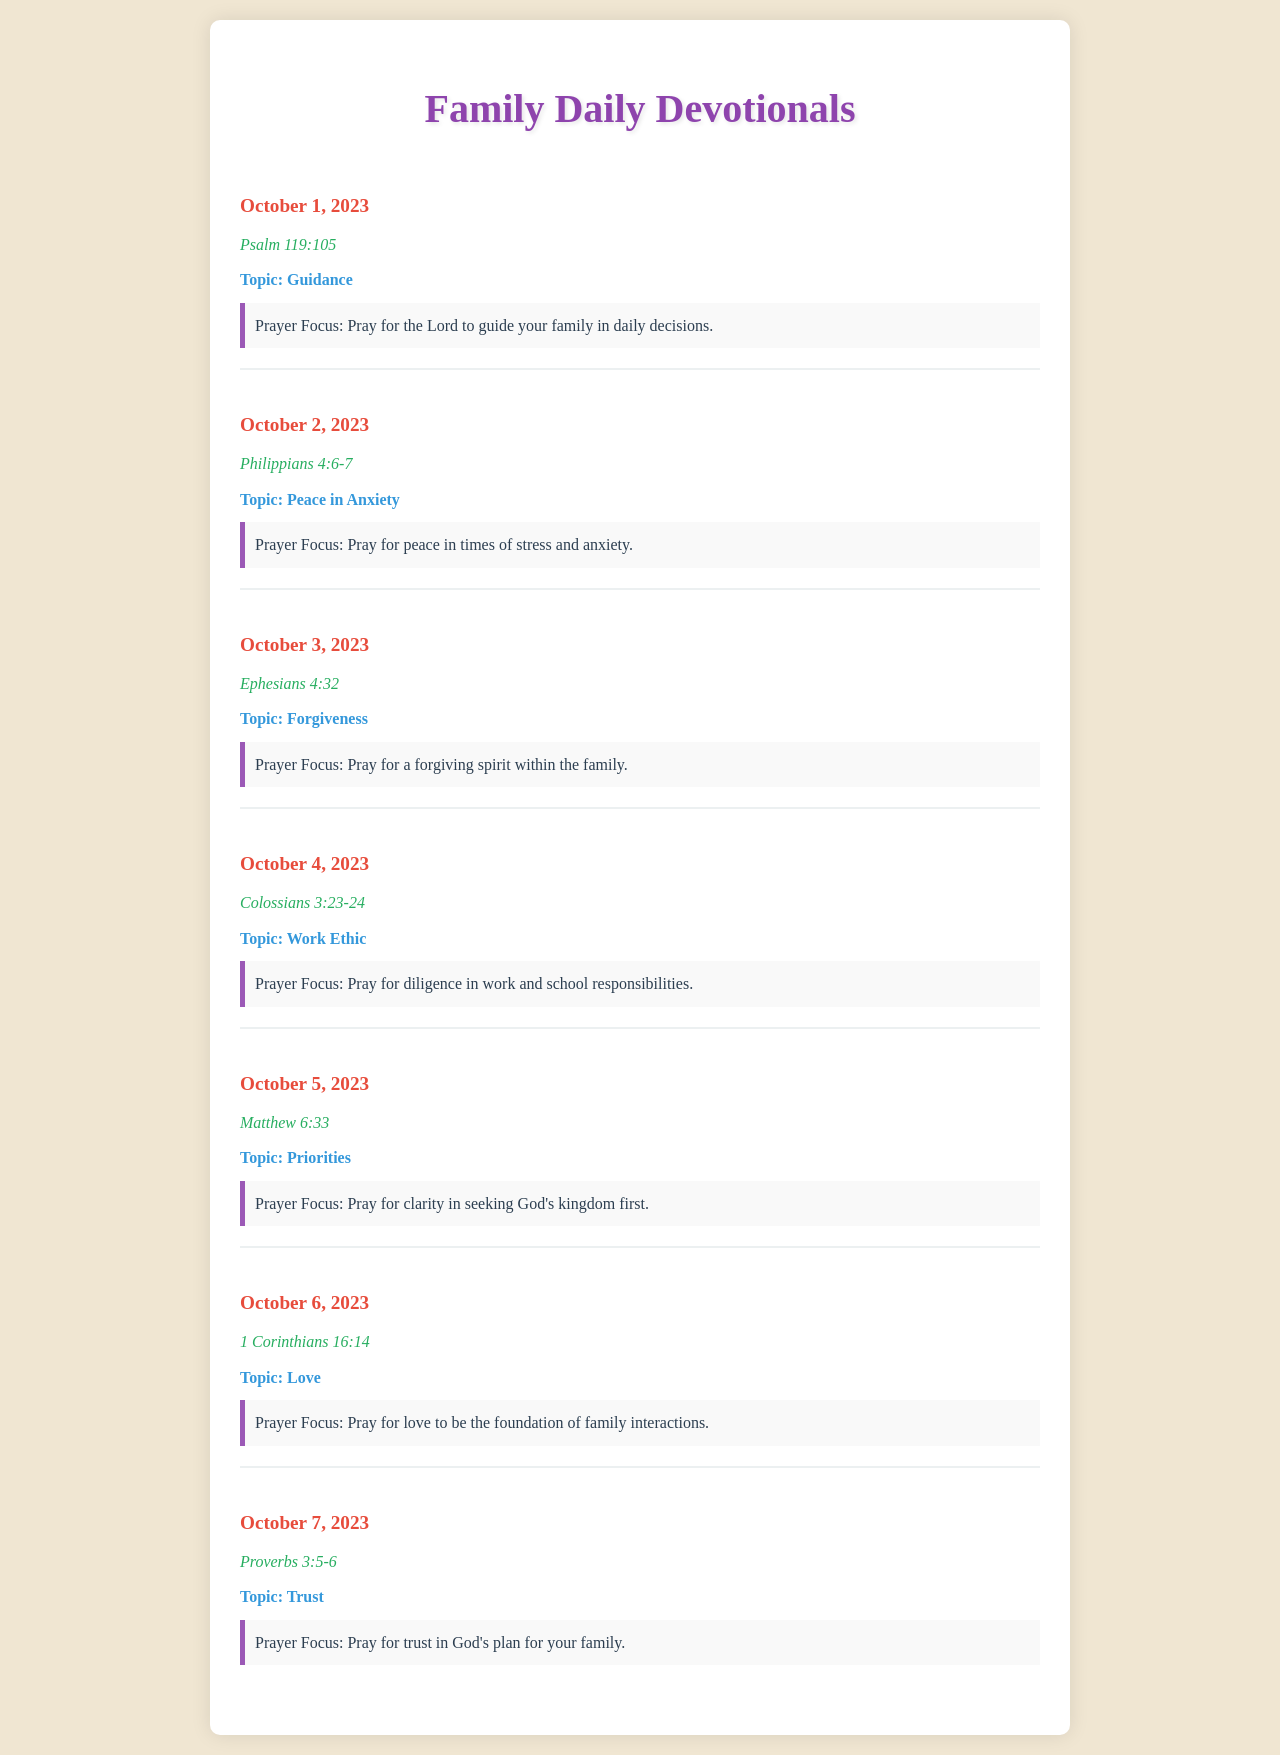What is the first scripture reading? The first scripture reading in the document is found under the date October 1, 2023.
Answer: Psalm 119:105 What is the prayer focus for October 3, 2023? The prayer focus for October 3, 2023 is listed as the same day under the topic of forgiveness.
Answer: Pray for a forgiving spirit within the family How many days of devotionals are listed? Counting from October 1 to October 7, there are seven entries for devotionals in the document.
Answer: 7 What is the topic for October 5, 2023? The topic for October 5, 2023 is specified in the document under that date.
Answer: Priorities What does the prayer focus for October 6, 2023 emphasize? The prayer focus highlights the importance of love in family interactions, as found in the document.
Answer: Pray for love to be the foundation of family interactions What scripture is referenced on October 4, 2023? The scripture for October 4, 2023 can be found next to the respective date in the document.
Answer: Colossians 3:23-24 